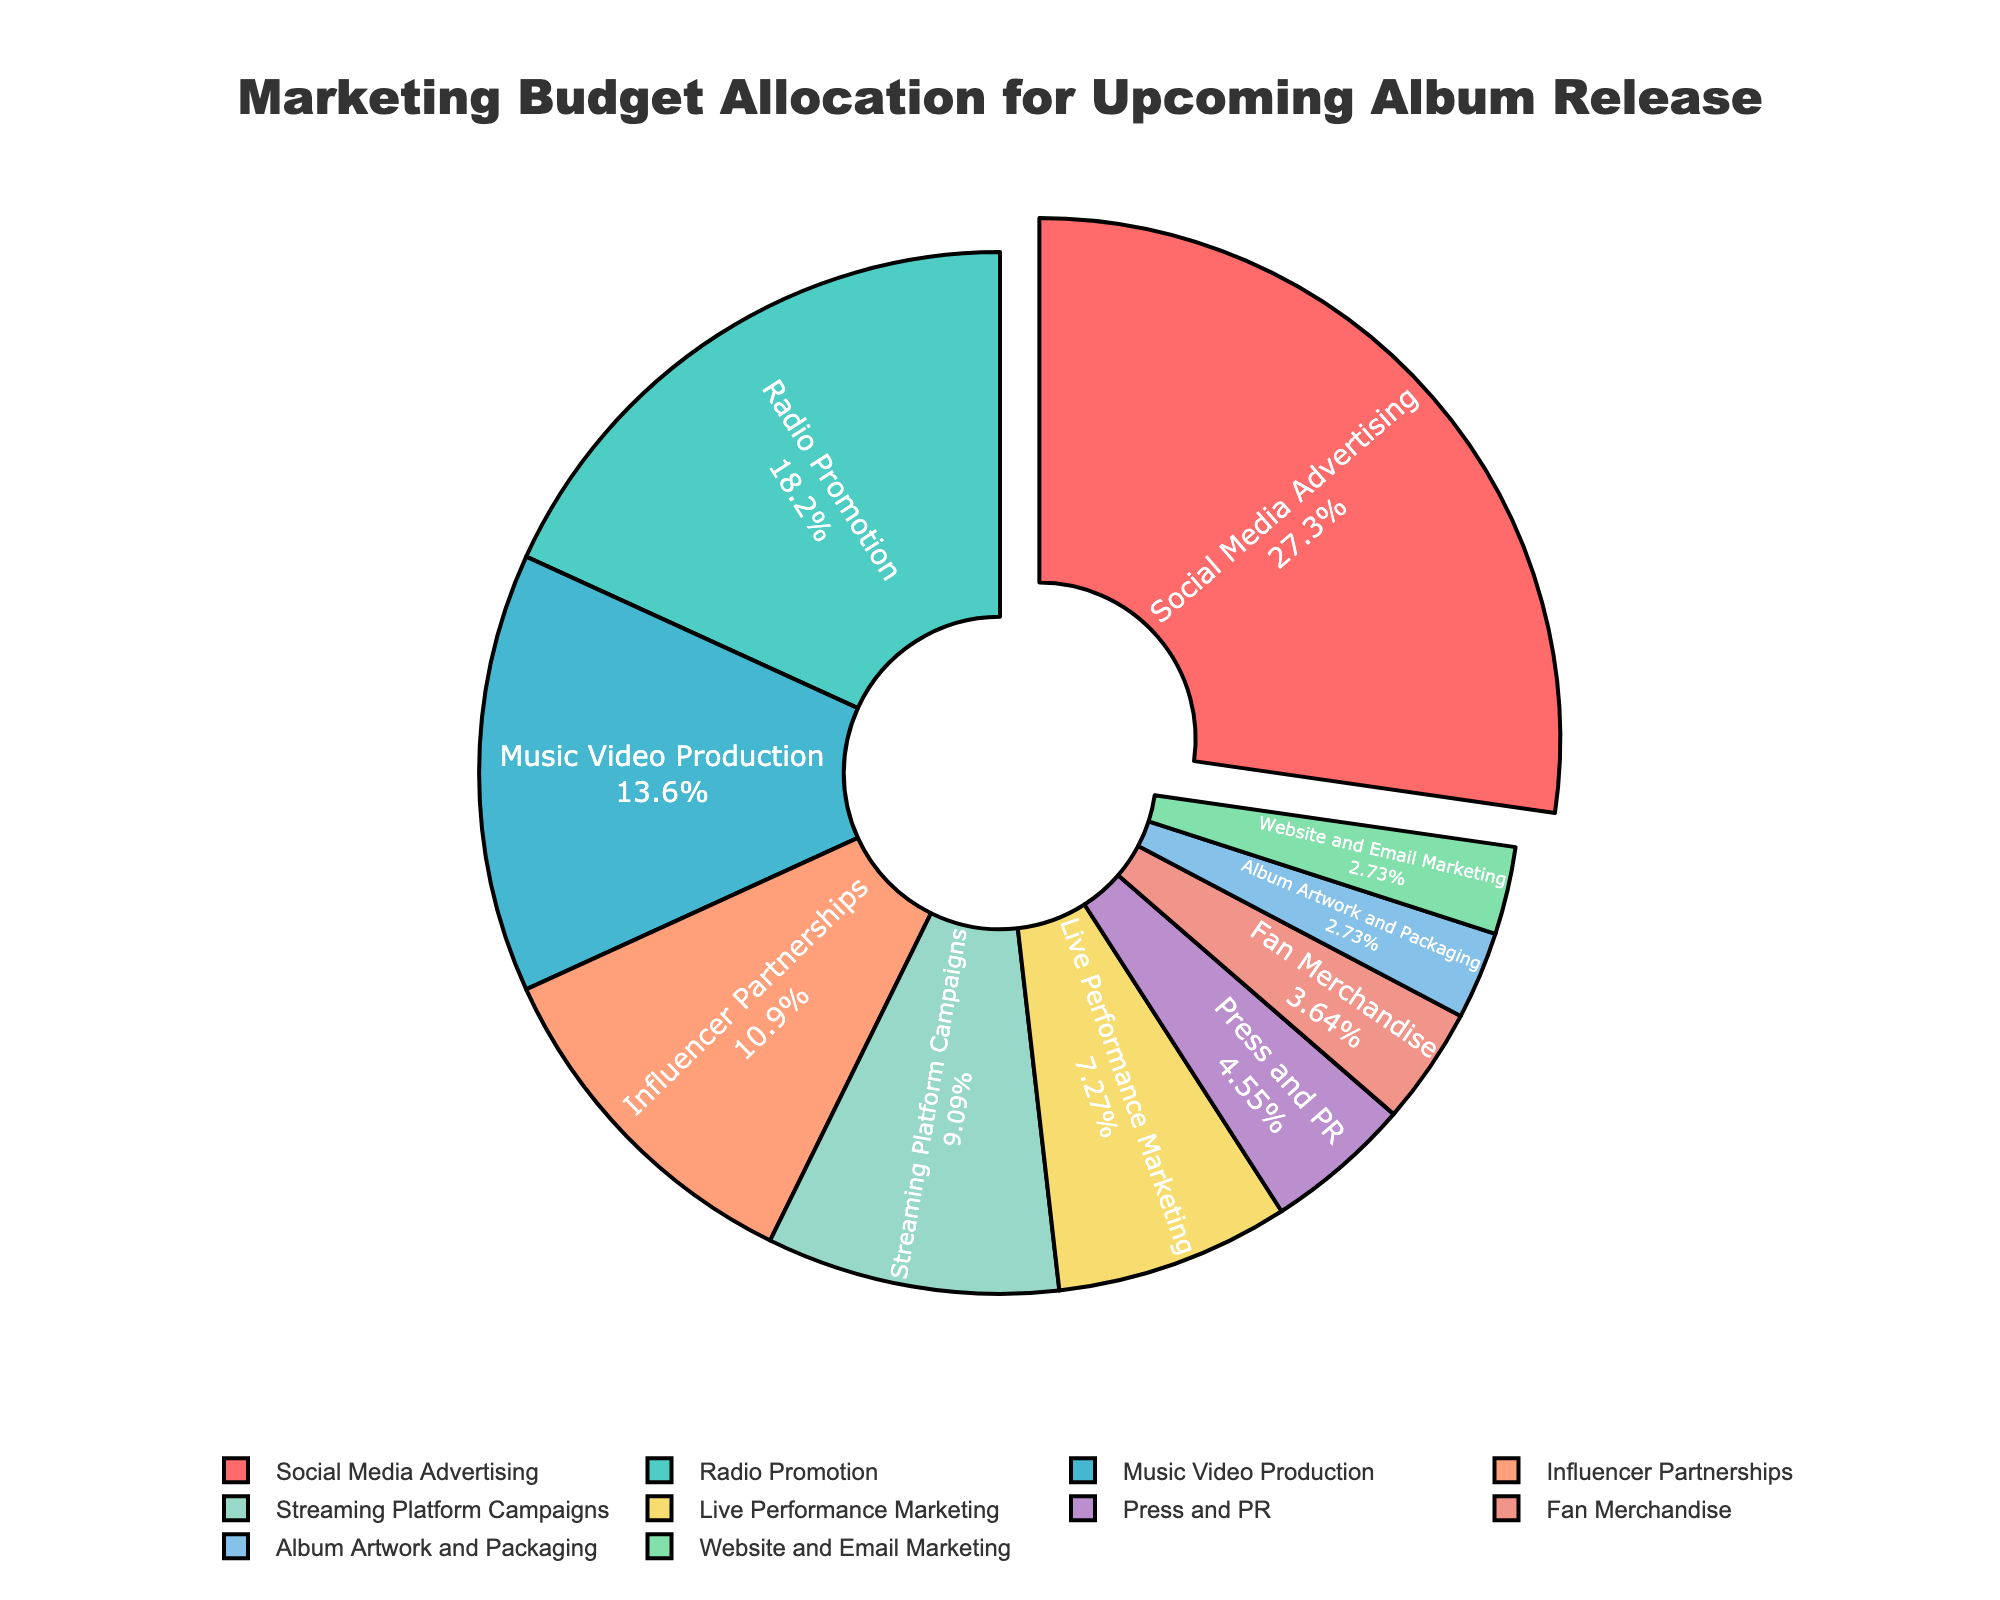What is the largest allocation of the marketing budget and what percentage does it receive? The pie chart shows that Social Media Advertising is the largest allocation of the marketing budget, receiving highlighted focus and showing 30%.
Answer: Social Media Advertising, 30% How much more is allocated to Radio Promotion compared to Fan Merchandise? To find this, we subtract the percentage of Fan Merchandise from Radio Promotion, which is 20% - 4% = 16%.
Answer: 16% Which two categories together makeup exactly 18% of the marketing budget? By inspecting the percentages, we find that Live Performance Marketing (8%) and Influencer Partnerships (12%) together make up 18% since 8% + 10% = 18%.
Answer: Live Performance Marketing and Influencer Partnerships Which category has the smallest allocation, and what is its percentage? The chart shows that Album Artwork and Packaging and Website and Email Marketing both share the smallest allocations, with each getting 3%.
Answer: Album Artwork and Packaging, 3%; Website and Email Marketing, 3% Which category is represented by the green color? The visual attribute of the pie chart shows that the green color represents Radio Promotion.
Answer: Radio Promotion How much more is allocated to Music Video Production than to Press and PR? Subtracting the percentage allocated to Press and PR from Music Video Production, we get 15% - 5% = 10%.
Answer: 10% What is the total percentage allocated to Social Media Advertising, Radio Promotion, and Streaming Platform Campaigns combined? Adding together these three percentages: 30% (Social Media Advertising) + 20% (Radio Promotion) + 10% (Streaming Platform Campaigns) = 60%.
Answer: 60% Which category stands out the most visually, and why? Social Media Advertising stands out the most visually because it is the largest segment and is slightly pulled out from the pie chart.
Answer: Social Media Advertising Comparing Live Performance Marketing and Album Artwork and Packaging, how many times larger is the allocation to the former? Live Performance Marketing has 8% and Album Artwork and Packaging has 3%, so the allocation to Live Performance Marketing is approximately 8% / 3% ≈ 2.67 times larger.
Answer: 2.67 times Which categories together make up less than or equal to 10%? The categories Fan Merchandise, Album Artwork and Packaging, and Website and Email Marketing each have 4%, 3%, and 3% respectively. Combined, they are 4% + 3% + 3% = 10%.
Answer: Fan Merchandise, Album Artwork and Packaging, and Website and Email Marketing 